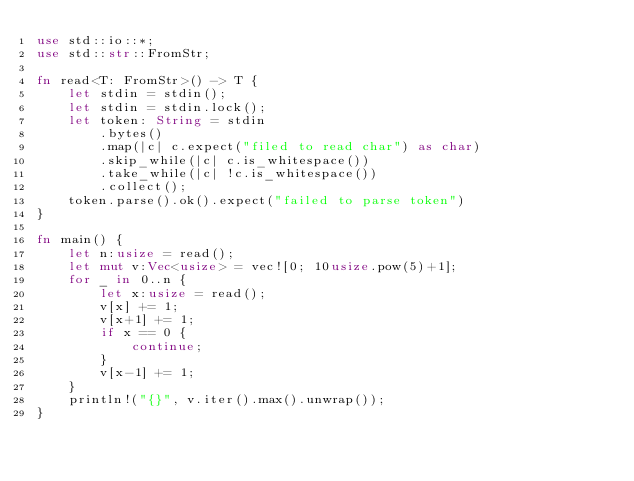Convert code to text. <code><loc_0><loc_0><loc_500><loc_500><_Rust_>use std::io::*;
use std::str::FromStr;

fn read<T: FromStr>() -> T {
    let stdin = stdin();
    let stdin = stdin.lock();
    let token: String = stdin
        .bytes()
        .map(|c| c.expect("filed to read char") as char)
        .skip_while(|c| c.is_whitespace())
        .take_while(|c| !c.is_whitespace())
        .collect();
    token.parse().ok().expect("failed to parse token")
}

fn main() {
    let n:usize = read();
    let mut v:Vec<usize> = vec![0; 10usize.pow(5)+1];
    for _ in 0..n {
        let x:usize = read();
        v[x] += 1;
        v[x+1] += 1;
        if x == 0 {
            continue;
        }
        v[x-1] += 1;
    }
    println!("{}", v.iter().max().unwrap());
}</code> 